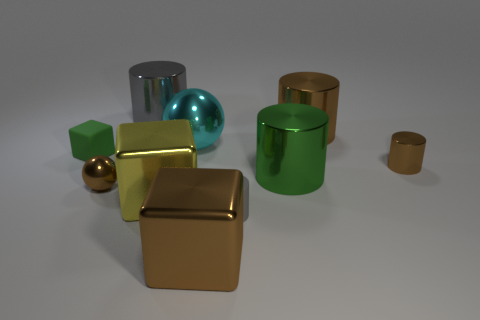Subtract 1 cylinders. How many cylinders are left? 4 Subtract all green cylinders. How many cylinders are left? 4 Subtract all large brown cylinders. How many cylinders are left? 4 Subtract all cyan cylinders. Subtract all green spheres. How many cylinders are left? 5 Subtract all cubes. How many objects are left? 7 Subtract all big green shiny things. Subtract all large gray things. How many objects are left? 8 Add 6 big balls. How many big balls are left? 7 Add 6 yellow metal blocks. How many yellow metal blocks exist? 7 Subtract 0 cyan cubes. How many objects are left? 10 